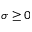<formula> <loc_0><loc_0><loc_500><loc_500>\sigma \geq 0</formula> 